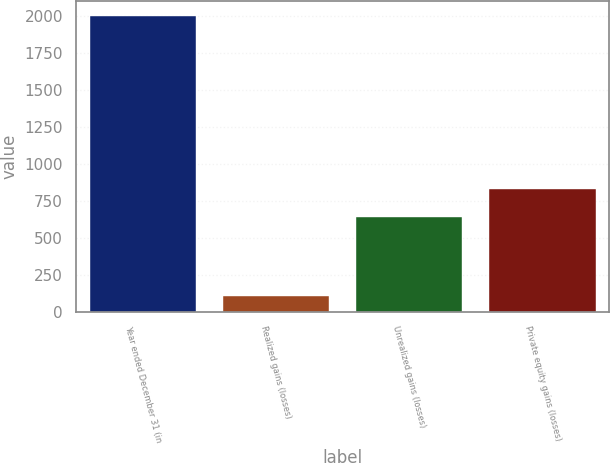<chart> <loc_0><loc_0><loc_500><loc_500><bar_chart><fcel>Year ended December 31 (in<fcel>Realized gains (losses)<fcel>Unrealized gains (losses)<fcel>Private equity gains (losses)<nl><fcel>2002<fcel>105<fcel>641<fcel>830.7<nl></chart> 